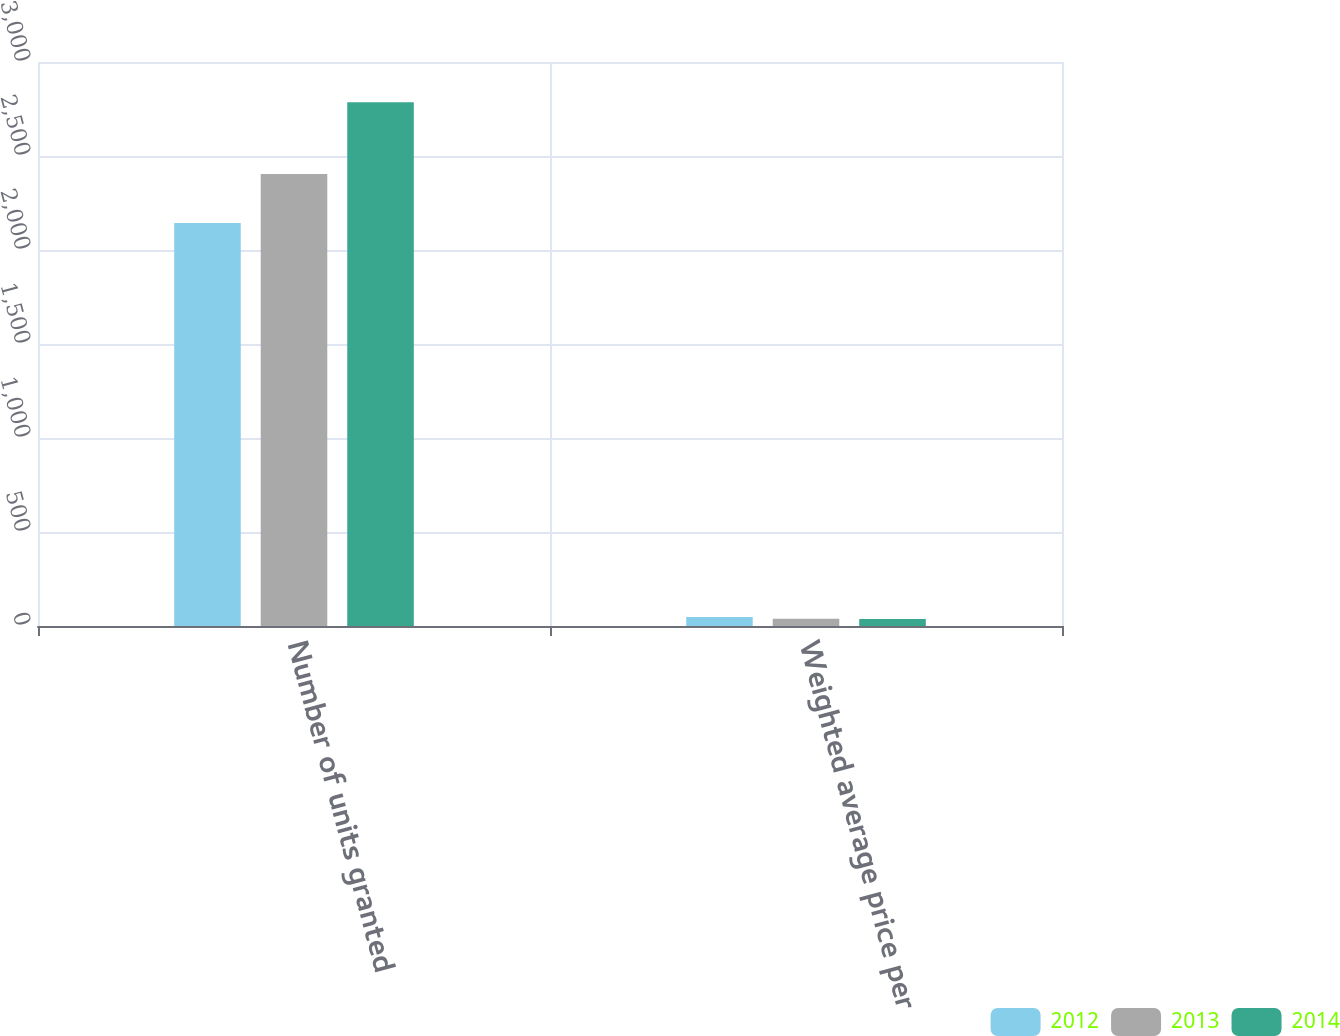Convert chart. <chart><loc_0><loc_0><loc_500><loc_500><stacked_bar_chart><ecel><fcel>Number of units granted<fcel>Weighted average price per<nl><fcel>2012<fcel>2144.1<fcel>48.49<nl><fcel>2013<fcel>2404.9<fcel>38.41<nl><fcel>2014<fcel>2785.7<fcel>37.29<nl></chart> 